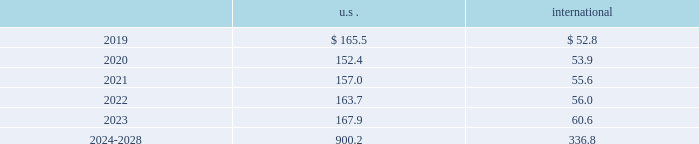The descriptions and fair value methodologies for the u.s .
And international pension plan assets are as follows : cash and cash equivalents the carrying amounts of cash and cash equivalents approximate fair value due to the short-term maturity .
Equity securities equity securities are valued at the closing market price reported on a u.s .
Or international exchange where the security is actively traded and are therefore classified as level 1 assets .
Equity mutual and pooled funds shares of mutual funds are valued at the net asset value ( nav ) of the fund and are classified as level 1 assets .
Units of pooled funds are valued at the per unit nav determined by the fund manager based on the value of the underlying traded holdings and are classified as level 2 assets .
Corporate and government bonds corporate and government bonds are classified as level 2 assets , as they are either valued at quoted market prices from observable pricing sources at the reporting date or valued based upon comparable securities with similar yields and credit ratings .
Other pooled funds other pooled funds classified as level 2 assets are valued at the nav of the shares held at year end , which is based on the fair value of the underlying investments .
Securities and interests classified as level 3 are carried at the estimated fair value .
The estimated fair value is based on the fair value of the underlying investment values , which includes estimated bids from brokers or other third-party vendor sources that utilize expected cash flow streams and other uncorroborated data including counterparty credit quality , default risk , discount rates , and the overall capital market liquidity .
Insurance contracts insurance contracts are classified as level 3 assets , as they are carried at contract value , which approximates the estimated fair value .
The estimated fair value is based on the fair value of the underlying investment of the insurance company and discount rates that require inputs with limited observability .
Contributions and projected benefit payments pension contributions to funded plans and benefit payments for unfunded plans for fiscal year 2018 were $ 68.3 .
Contributions for funded plans resulted primarily from contractual and regulatory requirements .
Benefit payments to unfunded plans were due primarily to the timing of retirements .
We anticipate contributing $ 45 to $ 65 to the defined benefit pension plans in fiscal year 2019 .
These contributions are anticipated to be driven primarily by contractual and regulatory requirements for funded plans and benefit payments for unfunded plans , which are dependent upon timing of retirements .
Projected benefit payments , which reflect expected future service , are as follows: .
These estimated benefit payments are based on assumptions about future events .
Actual benefit payments may vary significantly from these estimates. .
Considering the years 2024-2028 , what is the average for the u.s . estimated benefit payments by year? 
Rationale: it is the value expected for all the years in the period divided by 5 .
Computations: (900.2 / 5)
Answer: 180.04. 